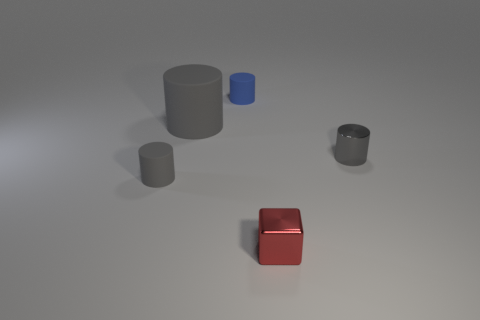Subtract all large gray matte cylinders. How many cylinders are left? 3 Subtract all blue cylinders. How many cylinders are left? 3 Add 1 shiny blocks. How many objects exist? 6 Subtract all green cubes. How many gray cylinders are left? 3 Add 1 gray cylinders. How many gray cylinders exist? 4 Subtract 0 gray cubes. How many objects are left? 5 Subtract all cylinders. How many objects are left? 1 Subtract 1 cubes. How many cubes are left? 0 Subtract all red cylinders. Subtract all blue spheres. How many cylinders are left? 4 Subtract all large green shiny things. Subtract all blue matte things. How many objects are left? 4 